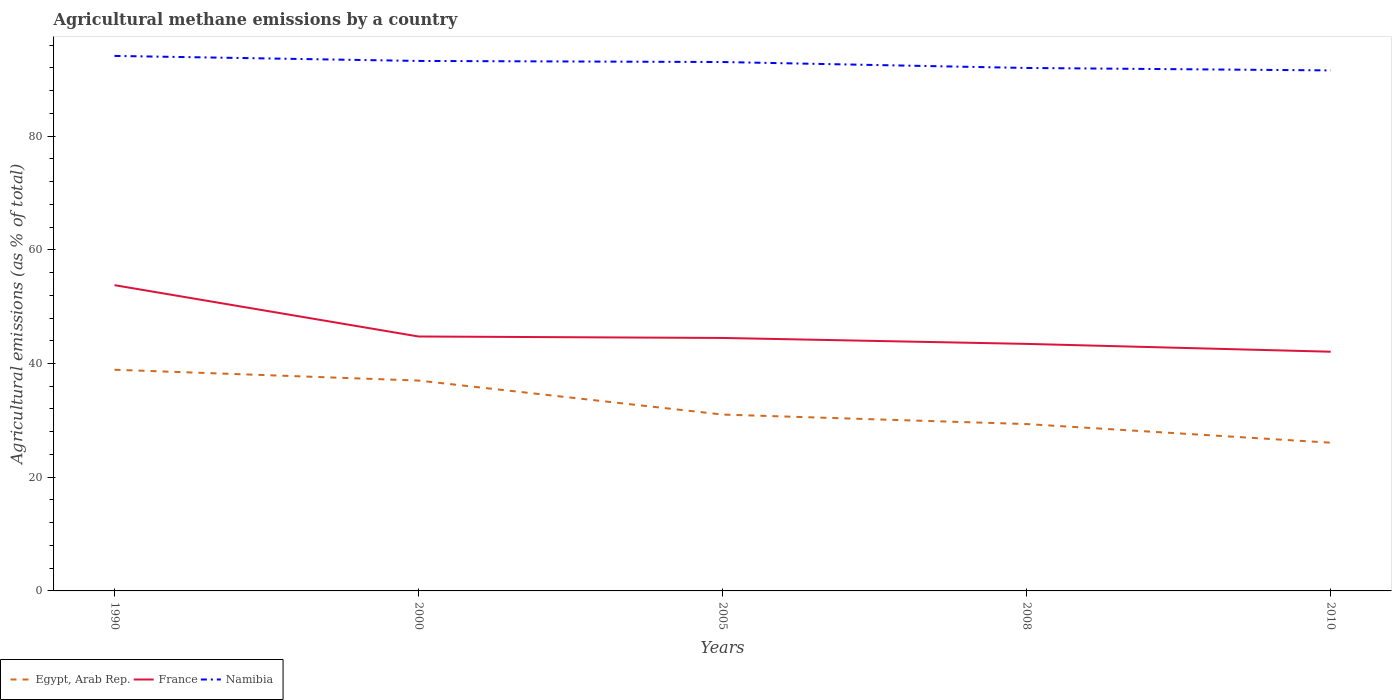How many different coloured lines are there?
Your answer should be compact. 3. Does the line corresponding to Namibia intersect with the line corresponding to France?
Provide a short and direct response. No. Is the number of lines equal to the number of legend labels?
Offer a very short reply. Yes. Across all years, what is the maximum amount of agricultural methane emitted in Namibia?
Offer a very short reply. 91.56. What is the total amount of agricultural methane emitted in France in the graph?
Provide a succinct answer. 9.03. What is the difference between the highest and the second highest amount of agricultural methane emitted in Namibia?
Provide a succinct answer. 2.55. What is the difference between the highest and the lowest amount of agricultural methane emitted in France?
Provide a short and direct response. 1. Is the amount of agricultural methane emitted in Namibia strictly greater than the amount of agricultural methane emitted in Egypt, Arab Rep. over the years?
Give a very brief answer. No. How many lines are there?
Offer a very short reply. 3. How many years are there in the graph?
Offer a very short reply. 5. Does the graph contain any zero values?
Keep it short and to the point. No. Does the graph contain grids?
Provide a succinct answer. No. How many legend labels are there?
Make the answer very short. 3. What is the title of the graph?
Keep it short and to the point. Agricultural methane emissions by a country. What is the label or title of the X-axis?
Offer a very short reply. Years. What is the label or title of the Y-axis?
Keep it short and to the point. Agricultural emissions (as % of total). What is the Agricultural emissions (as % of total) of Egypt, Arab Rep. in 1990?
Make the answer very short. 38.9. What is the Agricultural emissions (as % of total) in France in 1990?
Your answer should be compact. 53.78. What is the Agricultural emissions (as % of total) of Namibia in 1990?
Keep it short and to the point. 94.11. What is the Agricultural emissions (as % of total) in Egypt, Arab Rep. in 2000?
Your answer should be compact. 37. What is the Agricultural emissions (as % of total) in France in 2000?
Give a very brief answer. 44.75. What is the Agricultural emissions (as % of total) in Namibia in 2000?
Provide a short and direct response. 93.22. What is the Agricultural emissions (as % of total) of Egypt, Arab Rep. in 2005?
Offer a very short reply. 31.02. What is the Agricultural emissions (as % of total) in France in 2005?
Your response must be concise. 44.5. What is the Agricultural emissions (as % of total) of Namibia in 2005?
Ensure brevity in your answer.  93.03. What is the Agricultural emissions (as % of total) in Egypt, Arab Rep. in 2008?
Offer a terse response. 29.35. What is the Agricultural emissions (as % of total) of France in 2008?
Give a very brief answer. 43.45. What is the Agricultural emissions (as % of total) in Namibia in 2008?
Make the answer very short. 91.99. What is the Agricultural emissions (as % of total) of Egypt, Arab Rep. in 2010?
Your response must be concise. 26.07. What is the Agricultural emissions (as % of total) of France in 2010?
Your answer should be compact. 42.08. What is the Agricultural emissions (as % of total) of Namibia in 2010?
Make the answer very short. 91.56. Across all years, what is the maximum Agricultural emissions (as % of total) in Egypt, Arab Rep.?
Offer a very short reply. 38.9. Across all years, what is the maximum Agricultural emissions (as % of total) in France?
Your response must be concise. 53.78. Across all years, what is the maximum Agricultural emissions (as % of total) in Namibia?
Your answer should be very brief. 94.11. Across all years, what is the minimum Agricultural emissions (as % of total) in Egypt, Arab Rep.?
Your answer should be very brief. 26.07. Across all years, what is the minimum Agricultural emissions (as % of total) in France?
Keep it short and to the point. 42.08. Across all years, what is the minimum Agricultural emissions (as % of total) of Namibia?
Your answer should be compact. 91.56. What is the total Agricultural emissions (as % of total) in Egypt, Arab Rep. in the graph?
Your answer should be very brief. 162.35. What is the total Agricultural emissions (as % of total) in France in the graph?
Offer a terse response. 228.56. What is the total Agricultural emissions (as % of total) of Namibia in the graph?
Your response must be concise. 463.91. What is the difference between the Agricultural emissions (as % of total) in Egypt, Arab Rep. in 1990 and that in 2000?
Offer a very short reply. 1.9. What is the difference between the Agricultural emissions (as % of total) of France in 1990 and that in 2000?
Offer a terse response. 9.03. What is the difference between the Agricultural emissions (as % of total) of Namibia in 1990 and that in 2000?
Your answer should be compact. 0.88. What is the difference between the Agricultural emissions (as % of total) in Egypt, Arab Rep. in 1990 and that in 2005?
Ensure brevity in your answer.  7.88. What is the difference between the Agricultural emissions (as % of total) in France in 1990 and that in 2005?
Keep it short and to the point. 9.28. What is the difference between the Agricultural emissions (as % of total) in Namibia in 1990 and that in 2005?
Your answer should be compact. 1.07. What is the difference between the Agricultural emissions (as % of total) of Egypt, Arab Rep. in 1990 and that in 2008?
Your answer should be very brief. 9.55. What is the difference between the Agricultural emissions (as % of total) in France in 1990 and that in 2008?
Provide a succinct answer. 10.33. What is the difference between the Agricultural emissions (as % of total) of Namibia in 1990 and that in 2008?
Give a very brief answer. 2.12. What is the difference between the Agricultural emissions (as % of total) of Egypt, Arab Rep. in 1990 and that in 2010?
Give a very brief answer. 12.83. What is the difference between the Agricultural emissions (as % of total) in France in 1990 and that in 2010?
Provide a succinct answer. 11.71. What is the difference between the Agricultural emissions (as % of total) in Namibia in 1990 and that in 2010?
Offer a very short reply. 2.55. What is the difference between the Agricultural emissions (as % of total) of Egypt, Arab Rep. in 2000 and that in 2005?
Your answer should be compact. 5.98. What is the difference between the Agricultural emissions (as % of total) in France in 2000 and that in 2005?
Give a very brief answer. 0.26. What is the difference between the Agricultural emissions (as % of total) in Namibia in 2000 and that in 2005?
Your response must be concise. 0.19. What is the difference between the Agricultural emissions (as % of total) of Egypt, Arab Rep. in 2000 and that in 2008?
Keep it short and to the point. 7.65. What is the difference between the Agricultural emissions (as % of total) in France in 2000 and that in 2008?
Your answer should be very brief. 1.3. What is the difference between the Agricultural emissions (as % of total) of Namibia in 2000 and that in 2008?
Offer a very short reply. 1.24. What is the difference between the Agricultural emissions (as % of total) in Egypt, Arab Rep. in 2000 and that in 2010?
Ensure brevity in your answer.  10.93. What is the difference between the Agricultural emissions (as % of total) of France in 2000 and that in 2010?
Keep it short and to the point. 2.68. What is the difference between the Agricultural emissions (as % of total) in Namibia in 2000 and that in 2010?
Your response must be concise. 1.67. What is the difference between the Agricultural emissions (as % of total) in Egypt, Arab Rep. in 2005 and that in 2008?
Your answer should be very brief. 1.67. What is the difference between the Agricultural emissions (as % of total) of France in 2005 and that in 2008?
Your answer should be very brief. 1.04. What is the difference between the Agricultural emissions (as % of total) of Namibia in 2005 and that in 2008?
Provide a short and direct response. 1.05. What is the difference between the Agricultural emissions (as % of total) in Egypt, Arab Rep. in 2005 and that in 2010?
Your response must be concise. 4.95. What is the difference between the Agricultural emissions (as % of total) in France in 2005 and that in 2010?
Ensure brevity in your answer.  2.42. What is the difference between the Agricultural emissions (as % of total) of Namibia in 2005 and that in 2010?
Offer a very short reply. 1.48. What is the difference between the Agricultural emissions (as % of total) of Egypt, Arab Rep. in 2008 and that in 2010?
Give a very brief answer. 3.28. What is the difference between the Agricultural emissions (as % of total) of France in 2008 and that in 2010?
Provide a succinct answer. 1.38. What is the difference between the Agricultural emissions (as % of total) of Namibia in 2008 and that in 2010?
Offer a very short reply. 0.43. What is the difference between the Agricultural emissions (as % of total) in Egypt, Arab Rep. in 1990 and the Agricultural emissions (as % of total) in France in 2000?
Make the answer very short. -5.85. What is the difference between the Agricultural emissions (as % of total) of Egypt, Arab Rep. in 1990 and the Agricultural emissions (as % of total) of Namibia in 2000?
Provide a short and direct response. -54.32. What is the difference between the Agricultural emissions (as % of total) of France in 1990 and the Agricultural emissions (as % of total) of Namibia in 2000?
Your answer should be compact. -39.44. What is the difference between the Agricultural emissions (as % of total) of Egypt, Arab Rep. in 1990 and the Agricultural emissions (as % of total) of France in 2005?
Your answer should be compact. -5.59. What is the difference between the Agricultural emissions (as % of total) in Egypt, Arab Rep. in 1990 and the Agricultural emissions (as % of total) in Namibia in 2005?
Keep it short and to the point. -54.13. What is the difference between the Agricultural emissions (as % of total) of France in 1990 and the Agricultural emissions (as % of total) of Namibia in 2005?
Make the answer very short. -39.25. What is the difference between the Agricultural emissions (as % of total) of Egypt, Arab Rep. in 1990 and the Agricultural emissions (as % of total) of France in 2008?
Provide a short and direct response. -4.55. What is the difference between the Agricultural emissions (as % of total) of Egypt, Arab Rep. in 1990 and the Agricultural emissions (as % of total) of Namibia in 2008?
Give a very brief answer. -53.08. What is the difference between the Agricultural emissions (as % of total) in France in 1990 and the Agricultural emissions (as % of total) in Namibia in 2008?
Make the answer very short. -38.2. What is the difference between the Agricultural emissions (as % of total) in Egypt, Arab Rep. in 1990 and the Agricultural emissions (as % of total) in France in 2010?
Offer a terse response. -3.17. What is the difference between the Agricultural emissions (as % of total) in Egypt, Arab Rep. in 1990 and the Agricultural emissions (as % of total) in Namibia in 2010?
Keep it short and to the point. -52.65. What is the difference between the Agricultural emissions (as % of total) in France in 1990 and the Agricultural emissions (as % of total) in Namibia in 2010?
Provide a short and direct response. -37.77. What is the difference between the Agricultural emissions (as % of total) in Egypt, Arab Rep. in 2000 and the Agricultural emissions (as % of total) in France in 2005?
Provide a short and direct response. -7.5. What is the difference between the Agricultural emissions (as % of total) of Egypt, Arab Rep. in 2000 and the Agricultural emissions (as % of total) of Namibia in 2005?
Offer a terse response. -56.03. What is the difference between the Agricultural emissions (as % of total) in France in 2000 and the Agricultural emissions (as % of total) in Namibia in 2005?
Make the answer very short. -48.28. What is the difference between the Agricultural emissions (as % of total) of Egypt, Arab Rep. in 2000 and the Agricultural emissions (as % of total) of France in 2008?
Make the answer very short. -6.45. What is the difference between the Agricultural emissions (as % of total) of Egypt, Arab Rep. in 2000 and the Agricultural emissions (as % of total) of Namibia in 2008?
Offer a terse response. -54.99. What is the difference between the Agricultural emissions (as % of total) in France in 2000 and the Agricultural emissions (as % of total) in Namibia in 2008?
Provide a succinct answer. -47.23. What is the difference between the Agricultural emissions (as % of total) of Egypt, Arab Rep. in 2000 and the Agricultural emissions (as % of total) of France in 2010?
Your answer should be very brief. -5.07. What is the difference between the Agricultural emissions (as % of total) in Egypt, Arab Rep. in 2000 and the Agricultural emissions (as % of total) in Namibia in 2010?
Give a very brief answer. -54.56. What is the difference between the Agricultural emissions (as % of total) in France in 2000 and the Agricultural emissions (as % of total) in Namibia in 2010?
Provide a succinct answer. -46.8. What is the difference between the Agricultural emissions (as % of total) of Egypt, Arab Rep. in 2005 and the Agricultural emissions (as % of total) of France in 2008?
Offer a very short reply. -12.43. What is the difference between the Agricultural emissions (as % of total) of Egypt, Arab Rep. in 2005 and the Agricultural emissions (as % of total) of Namibia in 2008?
Make the answer very short. -60.97. What is the difference between the Agricultural emissions (as % of total) of France in 2005 and the Agricultural emissions (as % of total) of Namibia in 2008?
Keep it short and to the point. -47.49. What is the difference between the Agricultural emissions (as % of total) in Egypt, Arab Rep. in 2005 and the Agricultural emissions (as % of total) in France in 2010?
Provide a succinct answer. -11.05. What is the difference between the Agricultural emissions (as % of total) in Egypt, Arab Rep. in 2005 and the Agricultural emissions (as % of total) in Namibia in 2010?
Provide a succinct answer. -60.54. What is the difference between the Agricultural emissions (as % of total) in France in 2005 and the Agricultural emissions (as % of total) in Namibia in 2010?
Make the answer very short. -47.06. What is the difference between the Agricultural emissions (as % of total) of Egypt, Arab Rep. in 2008 and the Agricultural emissions (as % of total) of France in 2010?
Offer a terse response. -12.72. What is the difference between the Agricultural emissions (as % of total) in Egypt, Arab Rep. in 2008 and the Agricultural emissions (as % of total) in Namibia in 2010?
Keep it short and to the point. -62.21. What is the difference between the Agricultural emissions (as % of total) of France in 2008 and the Agricultural emissions (as % of total) of Namibia in 2010?
Your response must be concise. -48.1. What is the average Agricultural emissions (as % of total) of Egypt, Arab Rep. per year?
Offer a terse response. 32.47. What is the average Agricultural emissions (as % of total) of France per year?
Provide a short and direct response. 45.71. What is the average Agricultural emissions (as % of total) of Namibia per year?
Give a very brief answer. 92.78. In the year 1990, what is the difference between the Agricultural emissions (as % of total) of Egypt, Arab Rep. and Agricultural emissions (as % of total) of France?
Give a very brief answer. -14.88. In the year 1990, what is the difference between the Agricultural emissions (as % of total) in Egypt, Arab Rep. and Agricultural emissions (as % of total) in Namibia?
Make the answer very short. -55.2. In the year 1990, what is the difference between the Agricultural emissions (as % of total) in France and Agricultural emissions (as % of total) in Namibia?
Offer a terse response. -40.32. In the year 2000, what is the difference between the Agricultural emissions (as % of total) of Egypt, Arab Rep. and Agricultural emissions (as % of total) of France?
Make the answer very short. -7.75. In the year 2000, what is the difference between the Agricultural emissions (as % of total) of Egypt, Arab Rep. and Agricultural emissions (as % of total) of Namibia?
Ensure brevity in your answer.  -56.22. In the year 2000, what is the difference between the Agricultural emissions (as % of total) of France and Agricultural emissions (as % of total) of Namibia?
Provide a short and direct response. -48.47. In the year 2005, what is the difference between the Agricultural emissions (as % of total) in Egypt, Arab Rep. and Agricultural emissions (as % of total) in France?
Your response must be concise. -13.48. In the year 2005, what is the difference between the Agricultural emissions (as % of total) in Egypt, Arab Rep. and Agricultural emissions (as % of total) in Namibia?
Keep it short and to the point. -62.01. In the year 2005, what is the difference between the Agricultural emissions (as % of total) of France and Agricultural emissions (as % of total) of Namibia?
Provide a short and direct response. -48.53. In the year 2008, what is the difference between the Agricultural emissions (as % of total) of Egypt, Arab Rep. and Agricultural emissions (as % of total) of France?
Ensure brevity in your answer.  -14.1. In the year 2008, what is the difference between the Agricultural emissions (as % of total) in Egypt, Arab Rep. and Agricultural emissions (as % of total) in Namibia?
Keep it short and to the point. -62.64. In the year 2008, what is the difference between the Agricultural emissions (as % of total) of France and Agricultural emissions (as % of total) of Namibia?
Offer a very short reply. -48.53. In the year 2010, what is the difference between the Agricultural emissions (as % of total) of Egypt, Arab Rep. and Agricultural emissions (as % of total) of France?
Your answer should be very brief. -16. In the year 2010, what is the difference between the Agricultural emissions (as % of total) in Egypt, Arab Rep. and Agricultural emissions (as % of total) in Namibia?
Your answer should be very brief. -65.48. In the year 2010, what is the difference between the Agricultural emissions (as % of total) in France and Agricultural emissions (as % of total) in Namibia?
Your response must be concise. -49.48. What is the ratio of the Agricultural emissions (as % of total) in Egypt, Arab Rep. in 1990 to that in 2000?
Your answer should be compact. 1.05. What is the ratio of the Agricultural emissions (as % of total) in France in 1990 to that in 2000?
Offer a very short reply. 1.2. What is the ratio of the Agricultural emissions (as % of total) in Namibia in 1990 to that in 2000?
Offer a terse response. 1.01. What is the ratio of the Agricultural emissions (as % of total) of Egypt, Arab Rep. in 1990 to that in 2005?
Offer a terse response. 1.25. What is the ratio of the Agricultural emissions (as % of total) of France in 1990 to that in 2005?
Ensure brevity in your answer.  1.21. What is the ratio of the Agricultural emissions (as % of total) in Namibia in 1990 to that in 2005?
Your answer should be very brief. 1.01. What is the ratio of the Agricultural emissions (as % of total) in Egypt, Arab Rep. in 1990 to that in 2008?
Make the answer very short. 1.33. What is the ratio of the Agricultural emissions (as % of total) of France in 1990 to that in 2008?
Keep it short and to the point. 1.24. What is the ratio of the Agricultural emissions (as % of total) in Namibia in 1990 to that in 2008?
Provide a short and direct response. 1.02. What is the ratio of the Agricultural emissions (as % of total) in Egypt, Arab Rep. in 1990 to that in 2010?
Ensure brevity in your answer.  1.49. What is the ratio of the Agricultural emissions (as % of total) of France in 1990 to that in 2010?
Provide a short and direct response. 1.28. What is the ratio of the Agricultural emissions (as % of total) of Namibia in 1990 to that in 2010?
Your answer should be compact. 1.03. What is the ratio of the Agricultural emissions (as % of total) of Egypt, Arab Rep. in 2000 to that in 2005?
Provide a short and direct response. 1.19. What is the ratio of the Agricultural emissions (as % of total) in Egypt, Arab Rep. in 2000 to that in 2008?
Provide a short and direct response. 1.26. What is the ratio of the Agricultural emissions (as % of total) of France in 2000 to that in 2008?
Make the answer very short. 1.03. What is the ratio of the Agricultural emissions (as % of total) of Namibia in 2000 to that in 2008?
Your answer should be compact. 1.01. What is the ratio of the Agricultural emissions (as % of total) in Egypt, Arab Rep. in 2000 to that in 2010?
Provide a short and direct response. 1.42. What is the ratio of the Agricultural emissions (as % of total) of France in 2000 to that in 2010?
Your answer should be compact. 1.06. What is the ratio of the Agricultural emissions (as % of total) of Namibia in 2000 to that in 2010?
Keep it short and to the point. 1.02. What is the ratio of the Agricultural emissions (as % of total) in Egypt, Arab Rep. in 2005 to that in 2008?
Provide a short and direct response. 1.06. What is the ratio of the Agricultural emissions (as % of total) in Namibia in 2005 to that in 2008?
Provide a short and direct response. 1.01. What is the ratio of the Agricultural emissions (as % of total) of Egypt, Arab Rep. in 2005 to that in 2010?
Make the answer very short. 1.19. What is the ratio of the Agricultural emissions (as % of total) in France in 2005 to that in 2010?
Your answer should be compact. 1.06. What is the ratio of the Agricultural emissions (as % of total) in Namibia in 2005 to that in 2010?
Your response must be concise. 1.02. What is the ratio of the Agricultural emissions (as % of total) in Egypt, Arab Rep. in 2008 to that in 2010?
Provide a short and direct response. 1.13. What is the ratio of the Agricultural emissions (as % of total) in France in 2008 to that in 2010?
Give a very brief answer. 1.03. What is the difference between the highest and the second highest Agricultural emissions (as % of total) in Egypt, Arab Rep.?
Provide a succinct answer. 1.9. What is the difference between the highest and the second highest Agricultural emissions (as % of total) of France?
Ensure brevity in your answer.  9.03. What is the difference between the highest and the second highest Agricultural emissions (as % of total) in Namibia?
Offer a very short reply. 0.88. What is the difference between the highest and the lowest Agricultural emissions (as % of total) in Egypt, Arab Rep.?
Give a very brief answer. 12.83. What is the difference between the highest and the lowest Agricultural emissions (as % of total) in France?
Provide a succinct answer. 11.71. What is the difference between the highest and the lowest Agricultural emissions (as % of total) of Namibia?
Offer a very short reply. 2.55. 